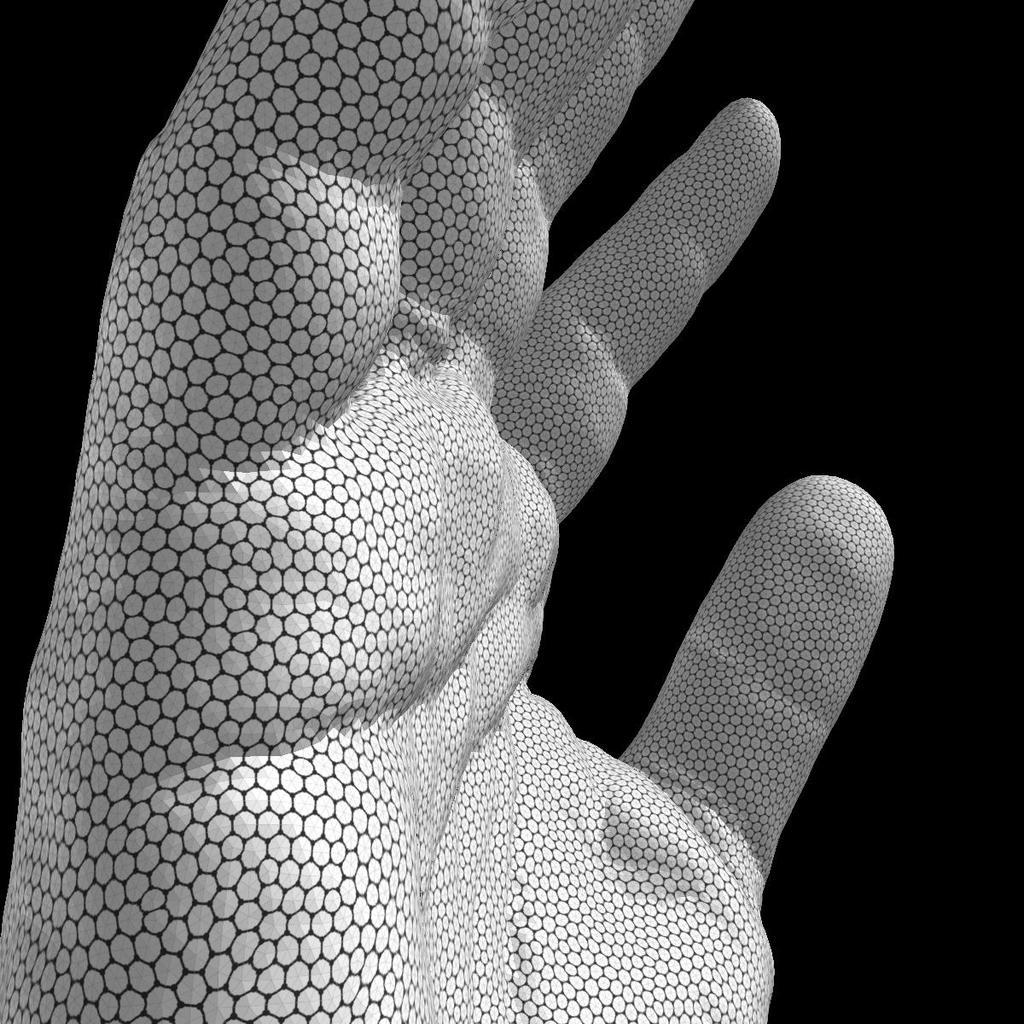What is the main subject in the foreground of the image? There is a model of a hand in the foreground of the image. What can be observed about the background of the image? The background of the image is dark. How many cakes are displayed on the lamp in the image? There is no lamp or cakes present in the image; it features a model of a hand in the foreground and a dark background. 